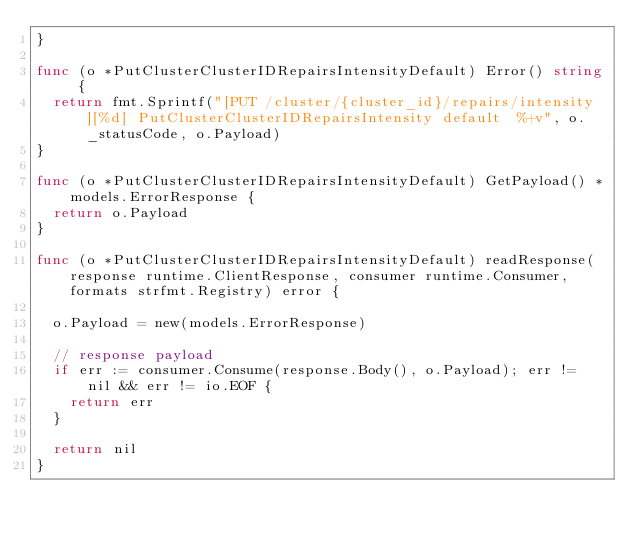<code> <loc_0><loc_0><loc_500><loc_500><_Go_>}

func (o *PutClusterClusterIDRepairsIntensityDefault) Error() string {
	return fmt.Sprintf("[PUT /cluster/{cluster_id}/repairs/intensity][%d] PutClusterClusterIDRepairsIntensity default  %+v", o._statusCode, o.Payload)
}

func (o *PutClusterClusterIDRepairsIntensityDefault) GetPayload() *models.ErrorResponse {
	return o.Payload
}

func (o *PutClusterClusterIDRepairsIntensityDefault) readResponse(response runtime.ClientResponse, consumer runtime.Consumer, formats strfmt.Registry) error {

	o.Payload = new(models.ErrorResponse)

	// response payload
	if err := consumer.Consume(response.Body(), o.Payload); err != nil && err != io.EOF {
		return err
	}

	return nil
}
</code> 